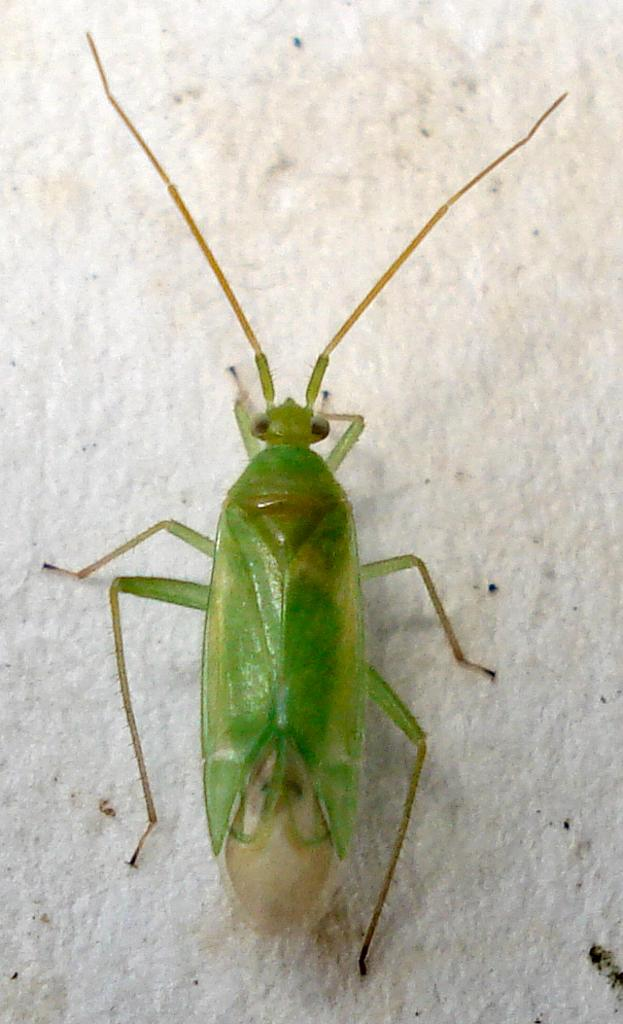What type of insect is present in the image? There is a green colored cockroach in the image. What type of apple is being used to explain the theory in the image? There is no apple or theory present in the image; it only features a green colored cockroach. 